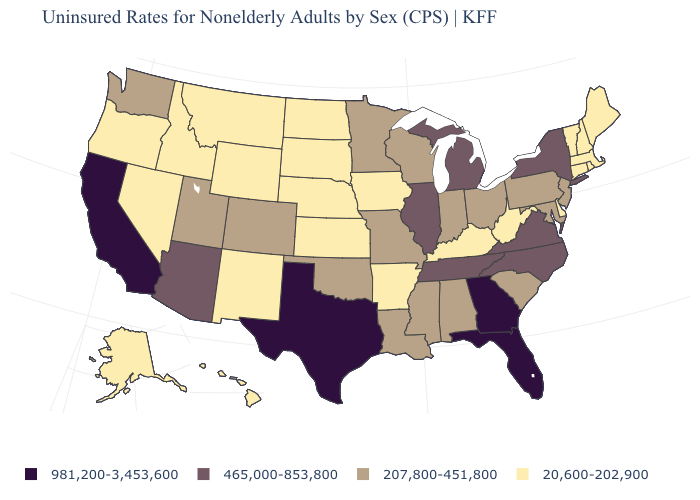What is the highest value in the West ?
Be succinct. 981,200-3,453,600. What is the value of Arizona?
Answer briefly. 465,000-853,800. Does Arkansas have the highest value in the USA?
Give a very brief answer. No. What is the value of Ohio?
Keep it brief. 207,800-451,800. What is the value of Rhode Island?
Give a very brief answer. 20,600-202,900. Does Georgia have the highest value in the USA?
Write a very short answer. Yes. What is the value of Texas?
Keep it brief. 981,200-3,453,600. What is the value of Colorado?
Quick response, please. 207,800-451,800. Name the states that have a value in the range 20,600-202,900?
Keep it brief. Alaska, Arkansas, Connecticut, Delaware, Hawaii, Idaho, Iowa, Kansas, Kentucky, Maine, Massachusetts, Montana, Nebraska, Nevada, New Hampshire, New Mexico, North Dakota, Oregon, Rhode Island, South Dakota, Vermont, West Virginia, Wyoming. Name the states that have a value in the range 465,000-853,800?
Short answer required. Arizona, Illinois, Michigan, New York, North Carolina, Tennessee, Virginia. Does Louisiana have a lower value than Alabama?
Be succinct. No. Among the states that border Nebraska , which have the lowest value?
Write a very short answer. Iowa, Kansas, South Dakota, Wyoming. Name the states that have a value in the range 465,000-853,800?
Be succinct. Arizona, Illinois, Michigan, New York, North Carolina, Tennessee, Virginia. Does the first symbol in the legend represent the smallest category?
Give a very brief answer. No. What is the highest value in the USA?
Be succinct. 981,200-3,453,600. 